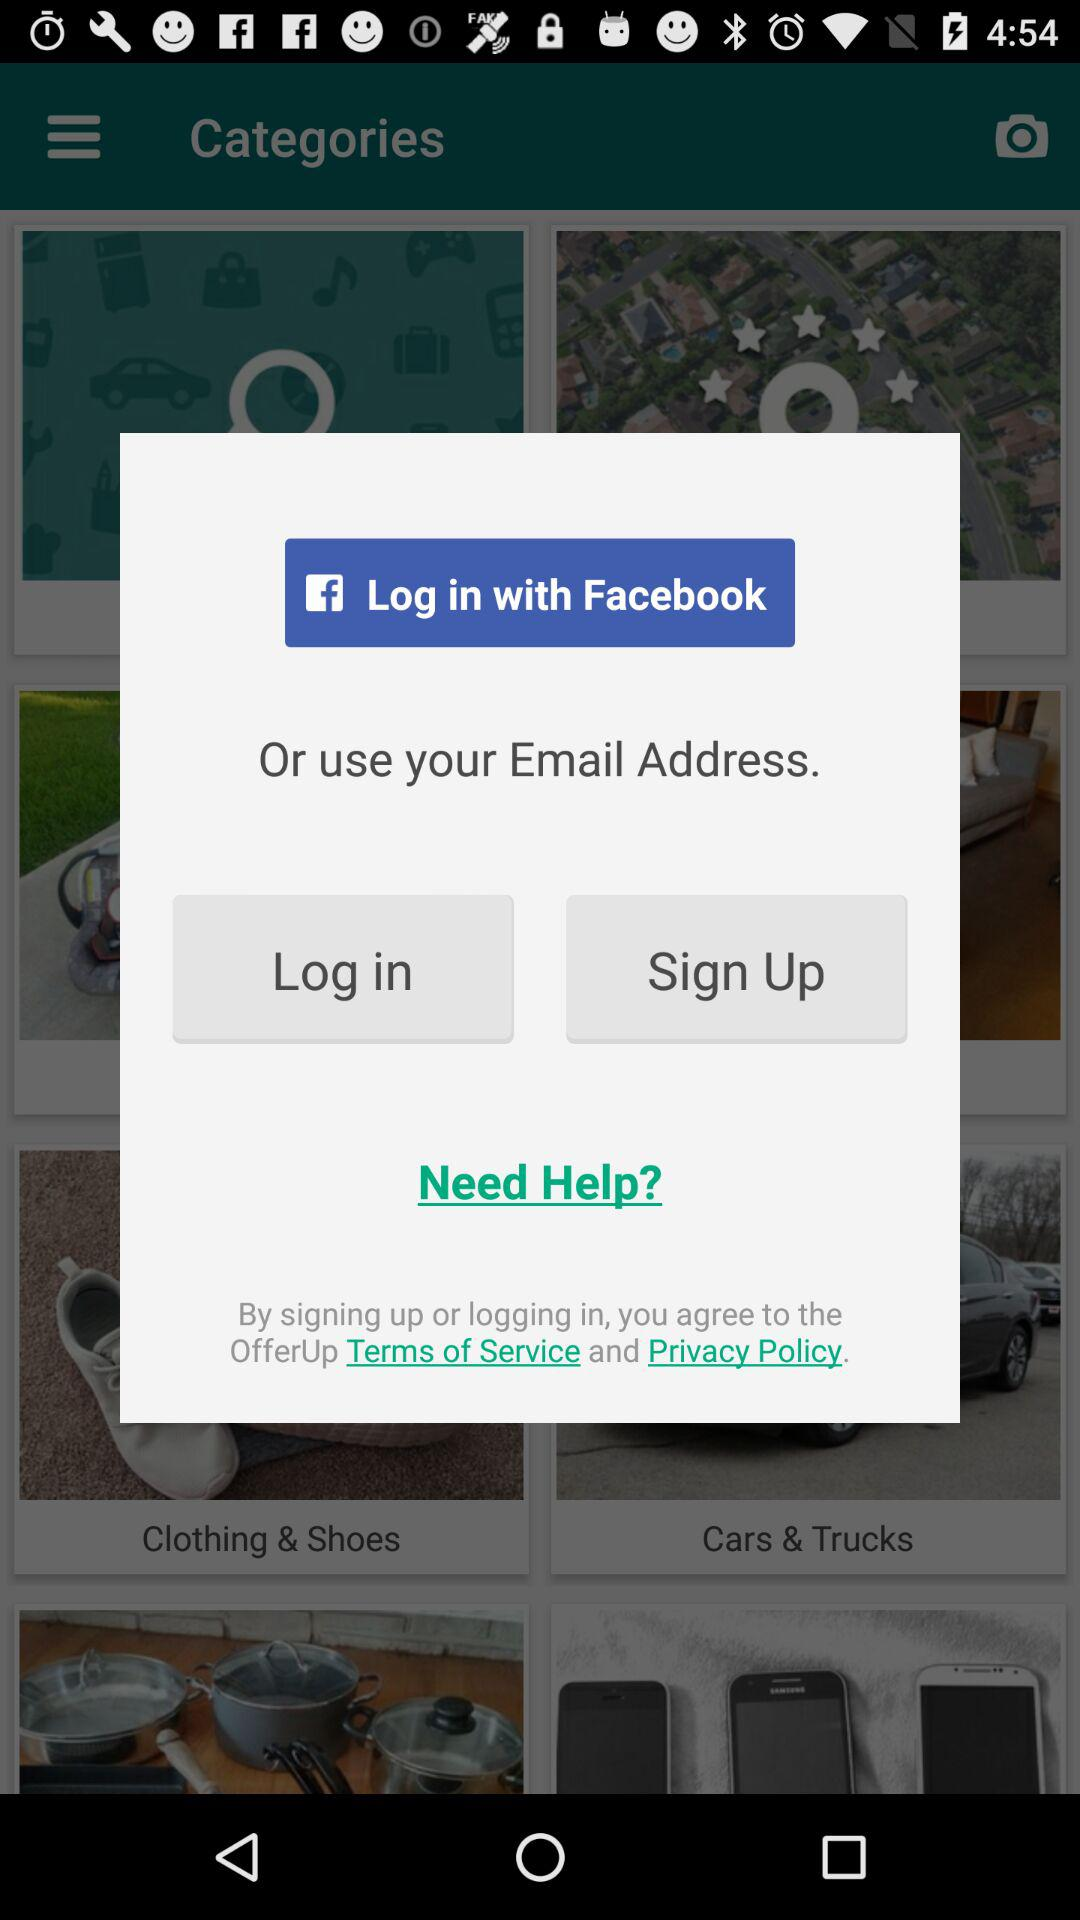What are the various login options? The various login options are "Facebook" and "Email Address". 